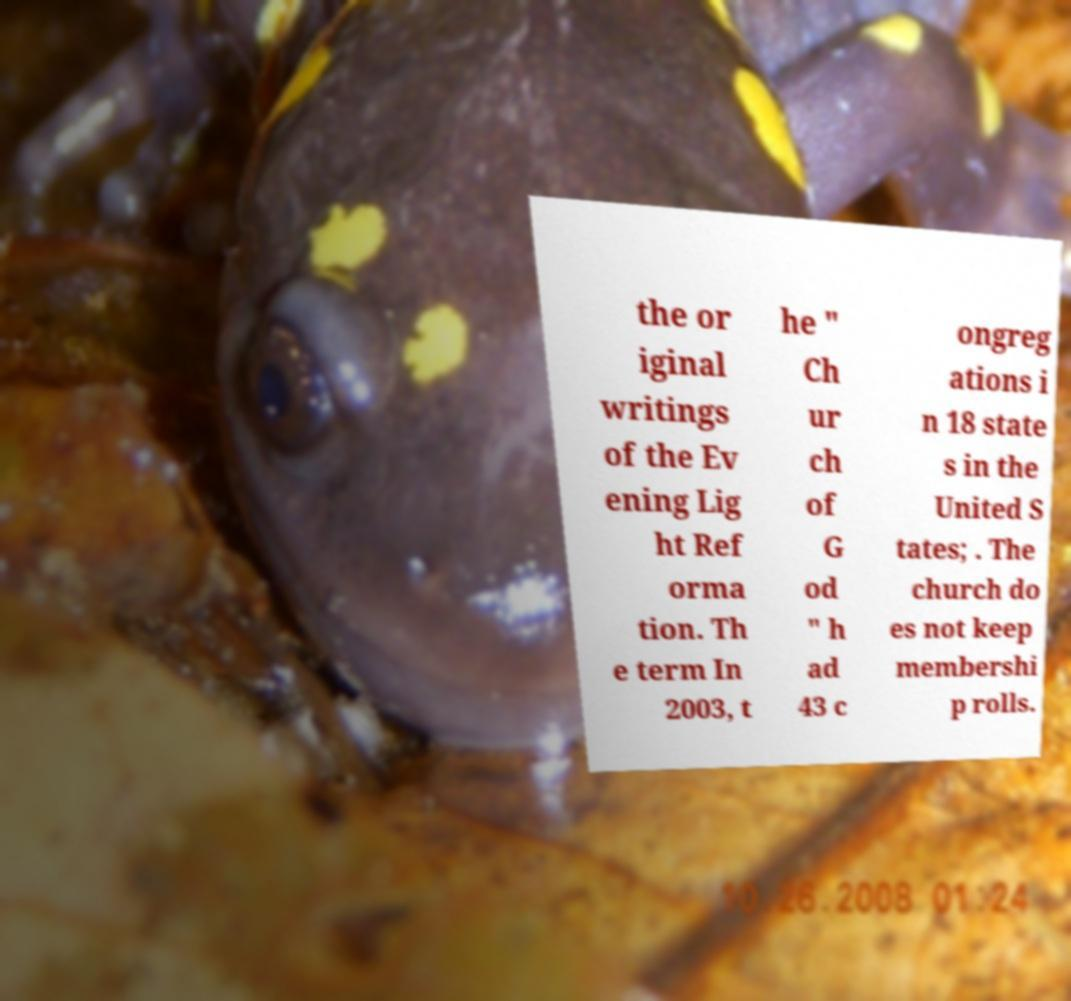I need the written content from this picture converted into text. Can you do that? the or iginal writings of the Ev ening Lig ht Ref orma tion. Th e term In 2003, t he " Ch ur ch of G od " h ad 43 c ongreg ations i n 18 state s in the United S tates; . The church do es not keep membershi p rolls. 